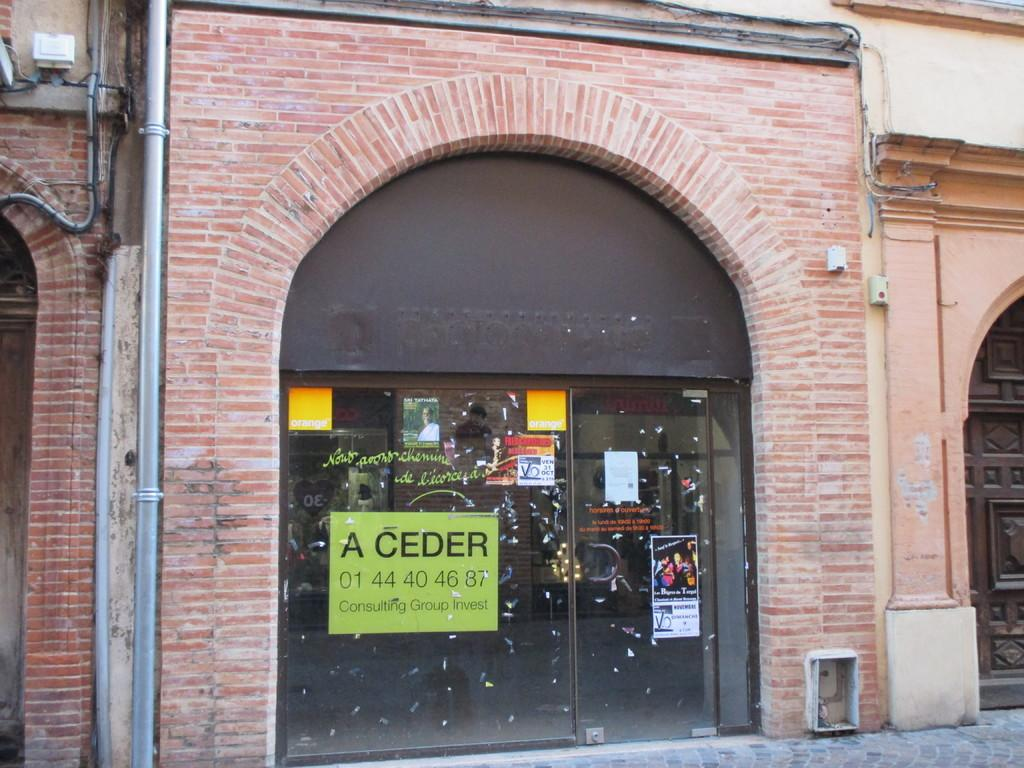What is the main structure visible in the image? There is a wall with doors in the image. What can be seen attached to the wall on the left side? Pipes are attached to the wall on the left side. What is attached to the glass door in the image? There are posters attached to a glass door. What type of path is visible at the right bottom of the image? There is a cobblestone path at the right bottom of the image. How many kittens are playing in the band on the throat of the image? There are no kittens or band present in the image, and the concept of a throat does not apply to a two-dimensional image. 